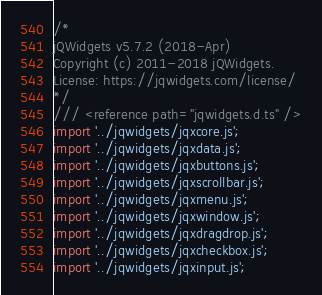<code> <loc_0><loc_0><loc_500><loc_500><_TypeScript_>/*
jQWidgets v5.7.2 (2018-Apr)
Copyright (c) 2011-2018 jQWidgets.
License: https://jqwidgets.com/license/
*/
/// <reference path="jqwidgets.d.ts" />
import '../jqwidgets/jqxcore.js';
import '../jqwidgets/jqxdata.js';
import '../jqwidgets/jqxbuttons.js';
import '../jqwidgets/jqxscrollbar.js';
import '../jqwidgets/jqxmenu.js';
import '../jqwidgets/jqxwindow.js';
import '../jqwidgets/jqxdragdrop.js';
import '../jqwidgets/jqxcheckbox.js';
import '../jqwidgets/jqxinput.js';</code> 